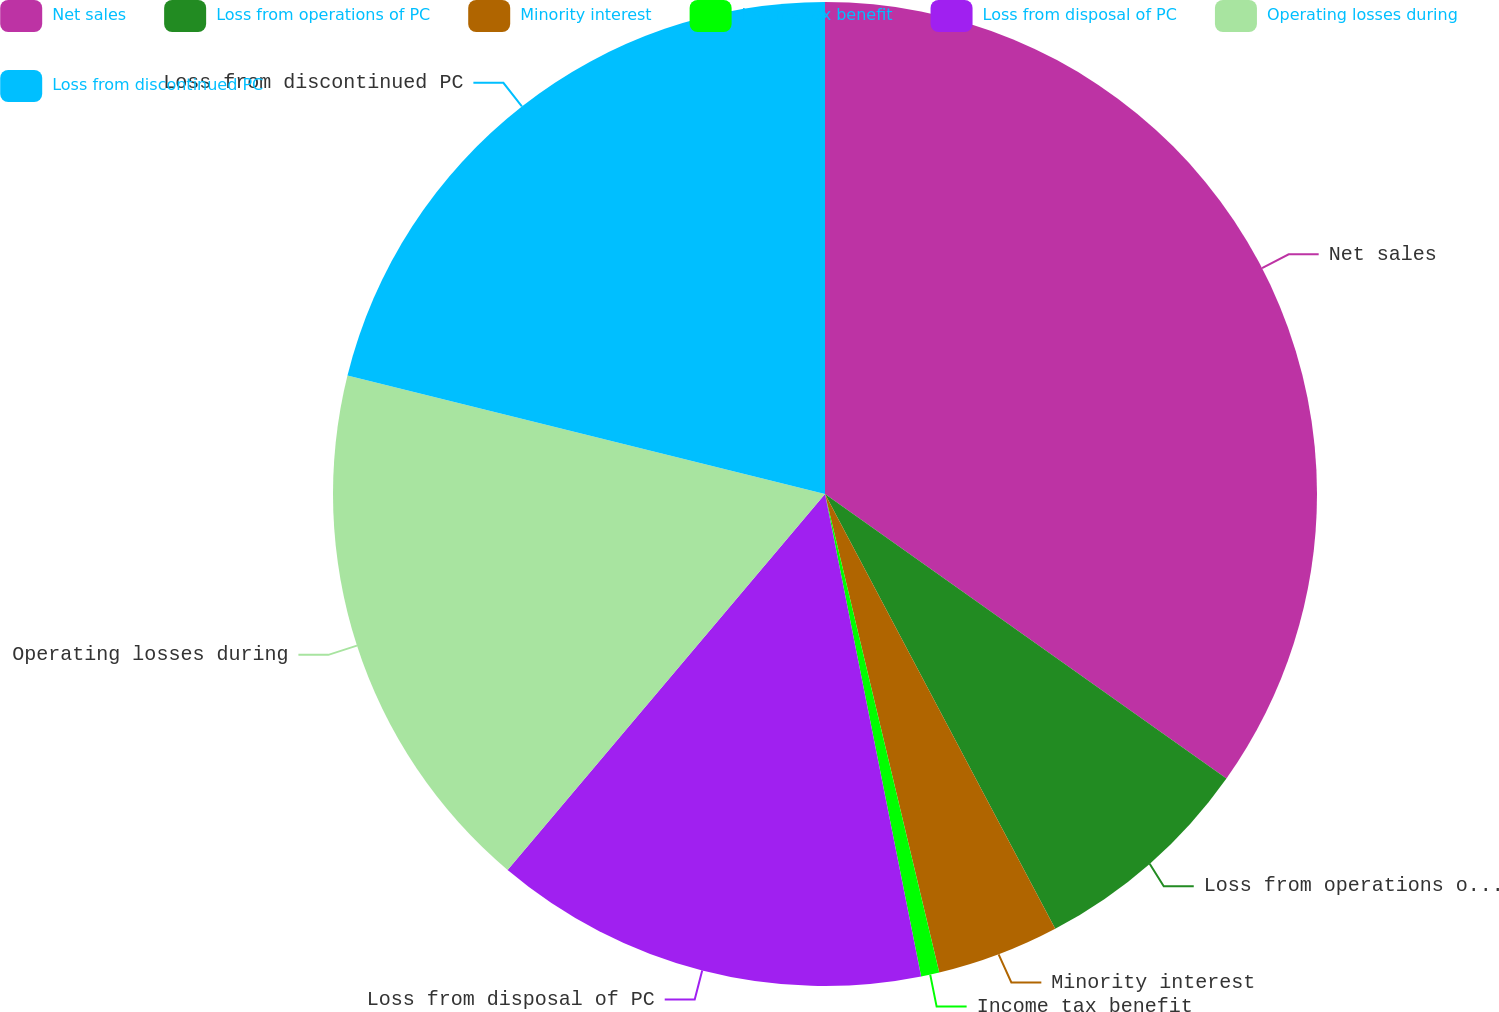Convert chart. <chart><loc_0><loc_0><loc_500><loc_500><pie_chart><fcel>Net sales<fcel>Loss from operations of PC<fcel>Minority interest<fcel>Income tax benefit<fcel>Loss from disposal of PC<fcel>Operating losses during<fcel>Loss from discontinued PC<nl><fcel>34.81%<fcel>7.44%<fcel>4.02%<fcel>0.6%<fcel>14.29%<fcel>17.71%<fcel>21.13%<nl></chart> 